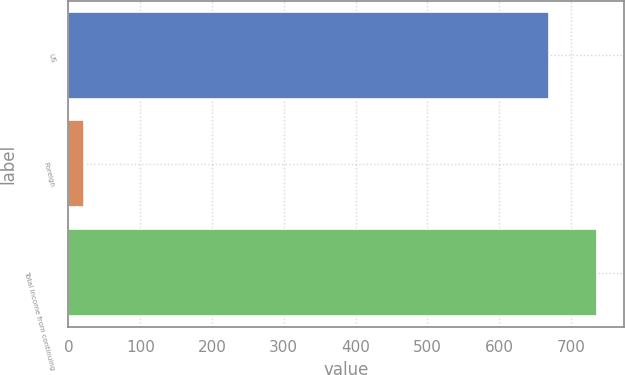Convert chart to OTSL. <chart><loc_0><loc_0><loc_500><loc_500><bar_chart><fcel>US<fcel>Foreign<fcel>Total income from continuing<nl><fcel>669.9<fcel>21.1<fcel>736.89<nl></chart> 